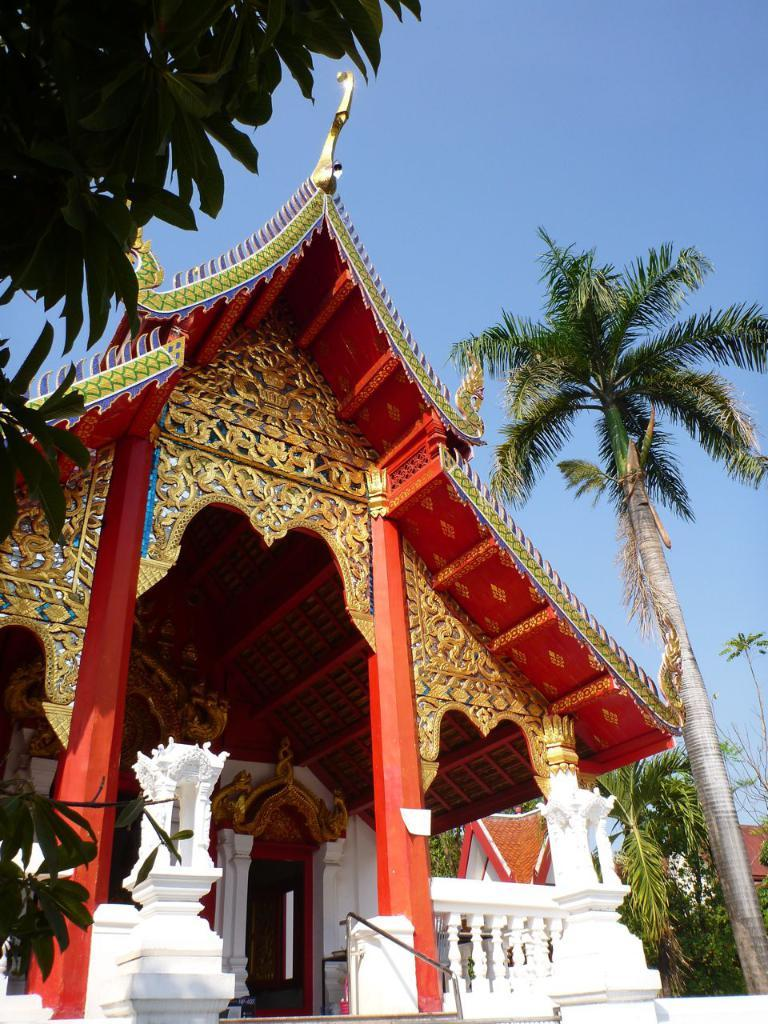What type of structure is depicted in the image? There is an architecture in the image. What can be seen on either side of the architecture? There are trees on either side of the architecture. What is visible in the background of the image? The sky is visible in the background of the image. How many legs can be seen on the tramp in the image? There is no tramp present in the image. What type of event is taking place in the image? The image does not depict any event; it shows an architecture with trees on either side and the sky in the background. 